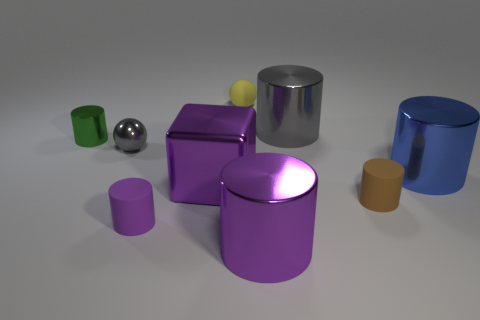What color is the other shiny object that is the same size as the green metal object?
Make the answer very short. Gray. There is a small cylinder on the left side of the tiny purple thing; how many tiny things are behind it?
Your response must be concise. 1. How many tiny things are both behind the big metal cube and in front of the matte sphere?
Your answer should be compact. 2. How many objects are gray metal things left of the big purple cube or tiny rubber cylinders that are on the left side of the small yellow ball?
Ensure brevity in your answer.  2. What number of other objects are there of the same size as the brown cylinder?
Your answer should be very brief. 4. There is a thing behind the gray thing to the right of the tiny gray thing; what is its shape?
Your answer should be compact. Sphere. There is a big cylinder behind the blue shiny cylinder; does it have the same color as the metallic sphere behind the brown cylinder?
Provide a short and direct response. Yes. Is there anything else that is the same color as the tiny shiny cylinder?
Offer a terse response. No. The shiny sphere has what color?
Your answer should be very brief. Gray. Are there any big green metallic blocks?
Keep it short and to the point. No. 